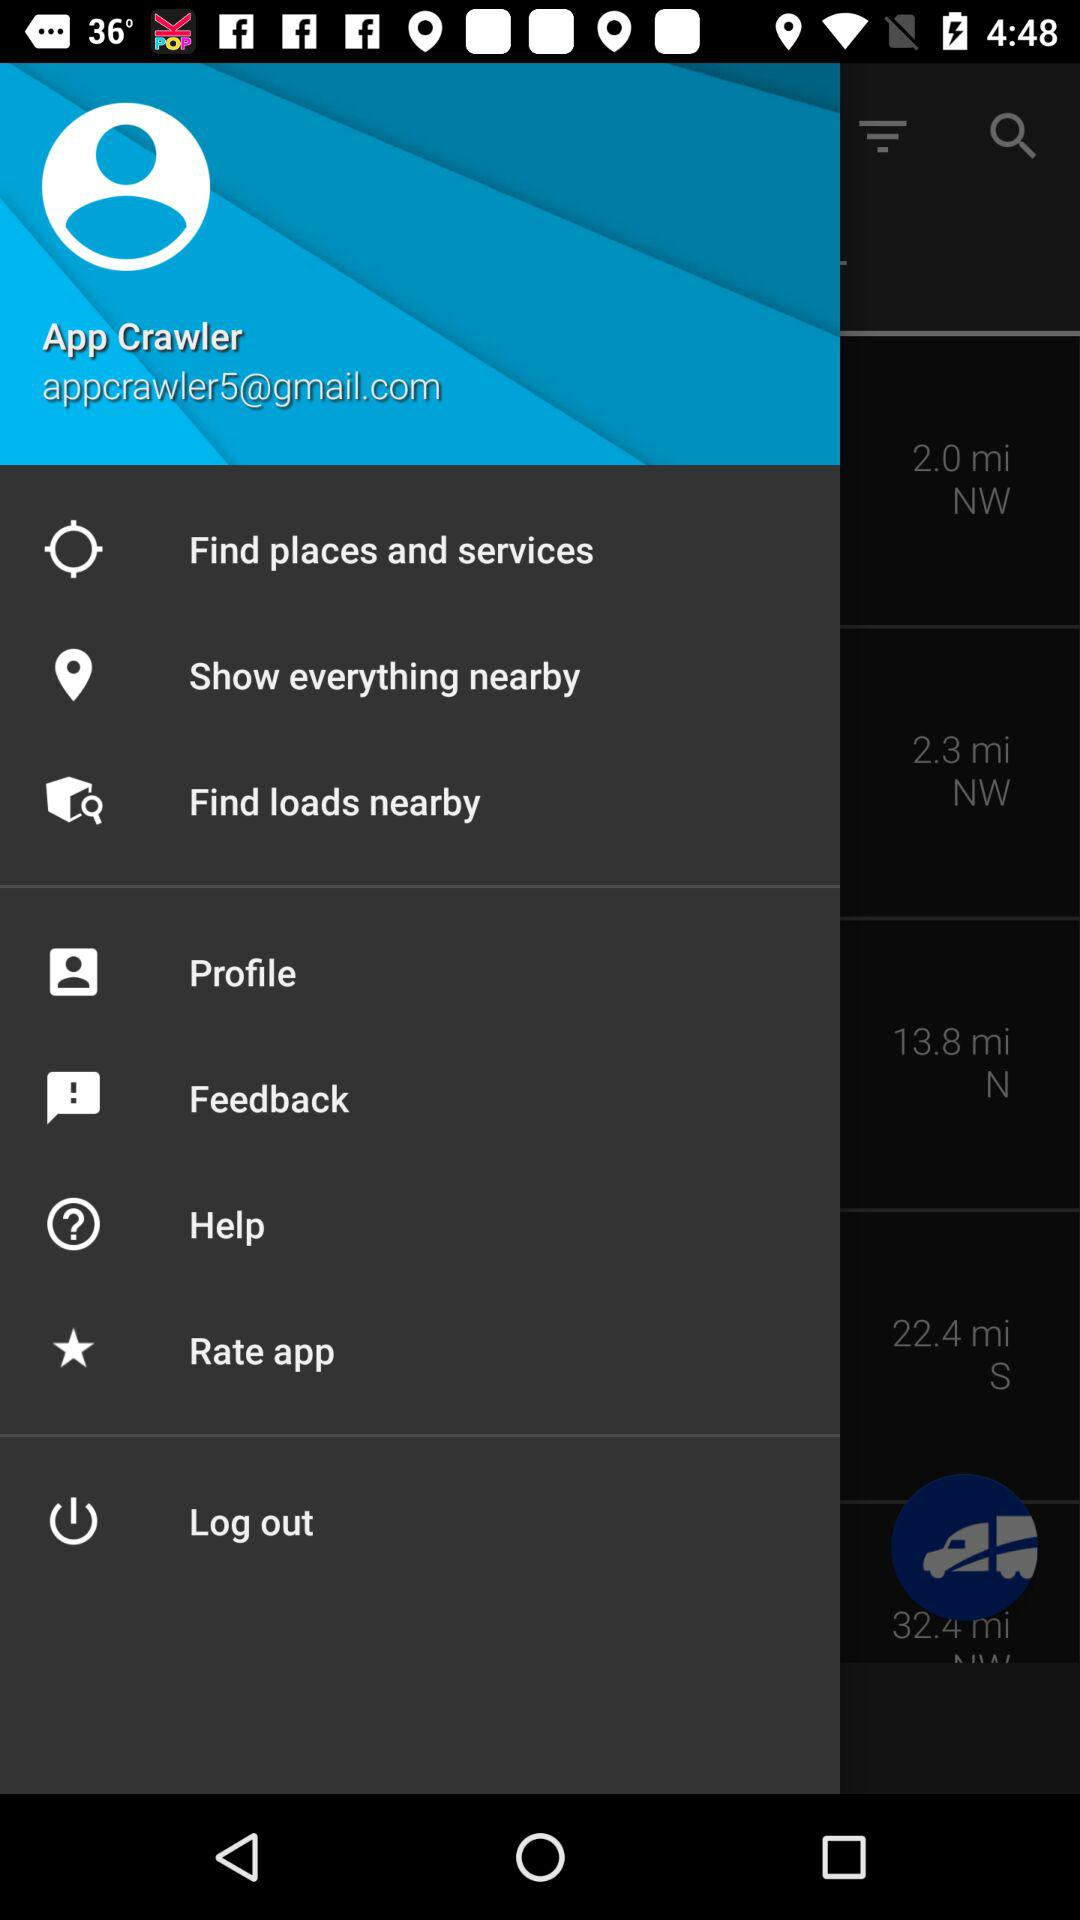What is the user's name? The user's name is App Crawler. 